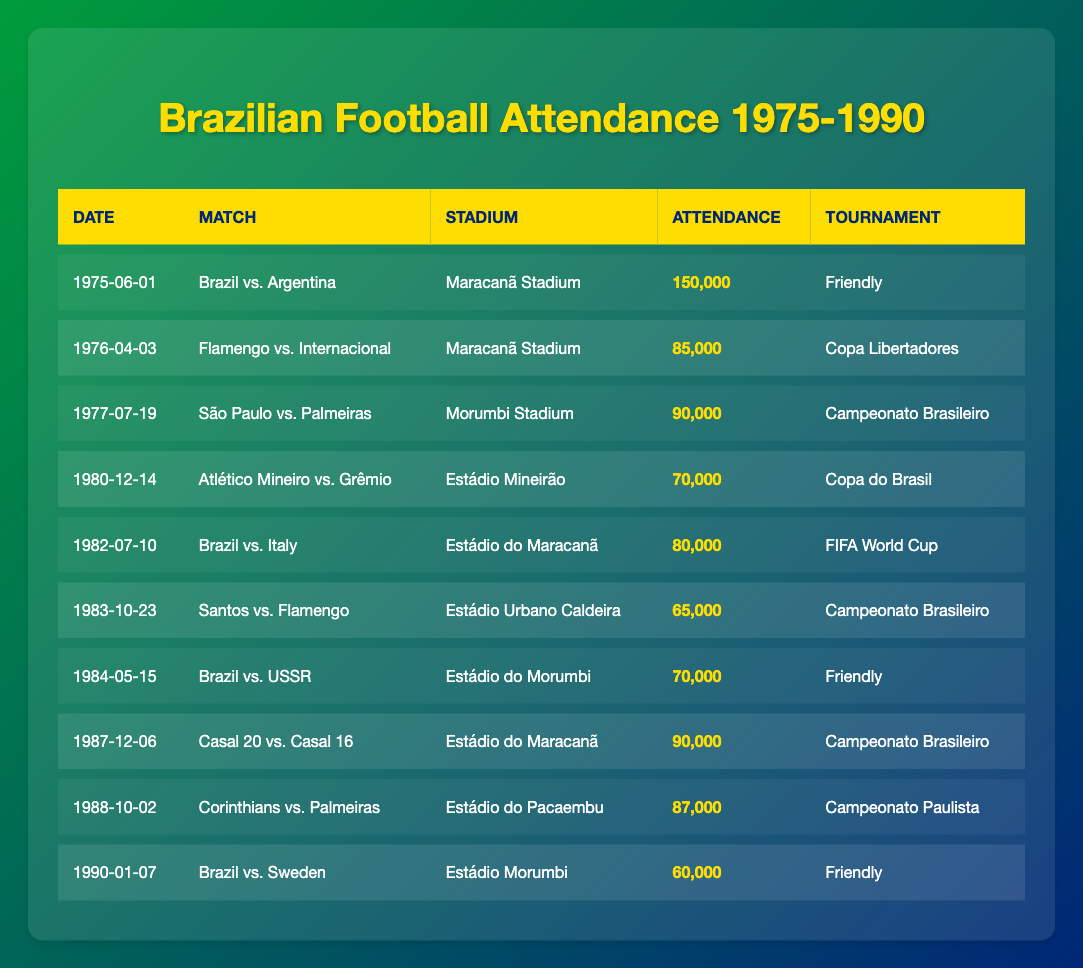What was the highest attendance recorded at a match in this table? Looking through the entries, the highest attendance was recorded at the match between Brazil and Argentina, with an attendance of 150,000.
Answer: 150,000 How many matches had an attendance greater than 80,000? The matches with attendances over 80,000 are: Brazil vs. Argentina (150,000), Flamengo vs. Internacional (85,000), São Paulo vs. Palmeiras (90,000), Atlético Mineiro vs. Grêmio (70,000), Brazil vs. Italy (80,000) and Casal 20 vs. Casal 16 (90,000), and Corinthians vs. Palmeiras (87,000). This totals to 5 matches.
Answer: 5 What is the average attendance for the matches listed? First, we sum the attendances: 150000 + 85000 + 90000 + 70000 + 80000 + 65000 + 70000 + 90000 + 87000 + 60000 =  1000000. Next, we divide by the number of matches which is 10, so the average attendance is 1000000 / 10 = 100000.
Answer: 100,000 Which stadium hosted more than two matches? The Maracanã Stadium hosted Brazil vs. Argentina, Flamengo vs. Internacional, and Casal 20 vs. Casal 16. Therefore, it hosted more than two matches.
Answer: Yes What was the attendance of the last match listed in the table? Referring to the last entry on the table, the attendance for the match Brazil vs. Sweden on January 7, 1990, was 60,000.
Answer: 60,000 In which tournament did Atlético Mineiro play against Grêmio? Atlético Mineiro played against Grêmio in the Copa do Brasil as indicated in the match details.
Answer: Copa do Brasil Which match had the lowest attendance? Looking at the attendance figures, Brazil vs. Sweden had the lowest attendance of 60,000.
Answer: 60,000 How many different tournaments had attendances above 80,000? The tournaments with attendances over 80,000 include Friendly, Copa Libertadores and Campeonato Brasileiro. Counting their unique occurrences gives us three different tournaments: Friendly (2), Copa Libertadores (1), and Campeonato Brasileiro (2). The distinct count is 3.
Answer: 3 